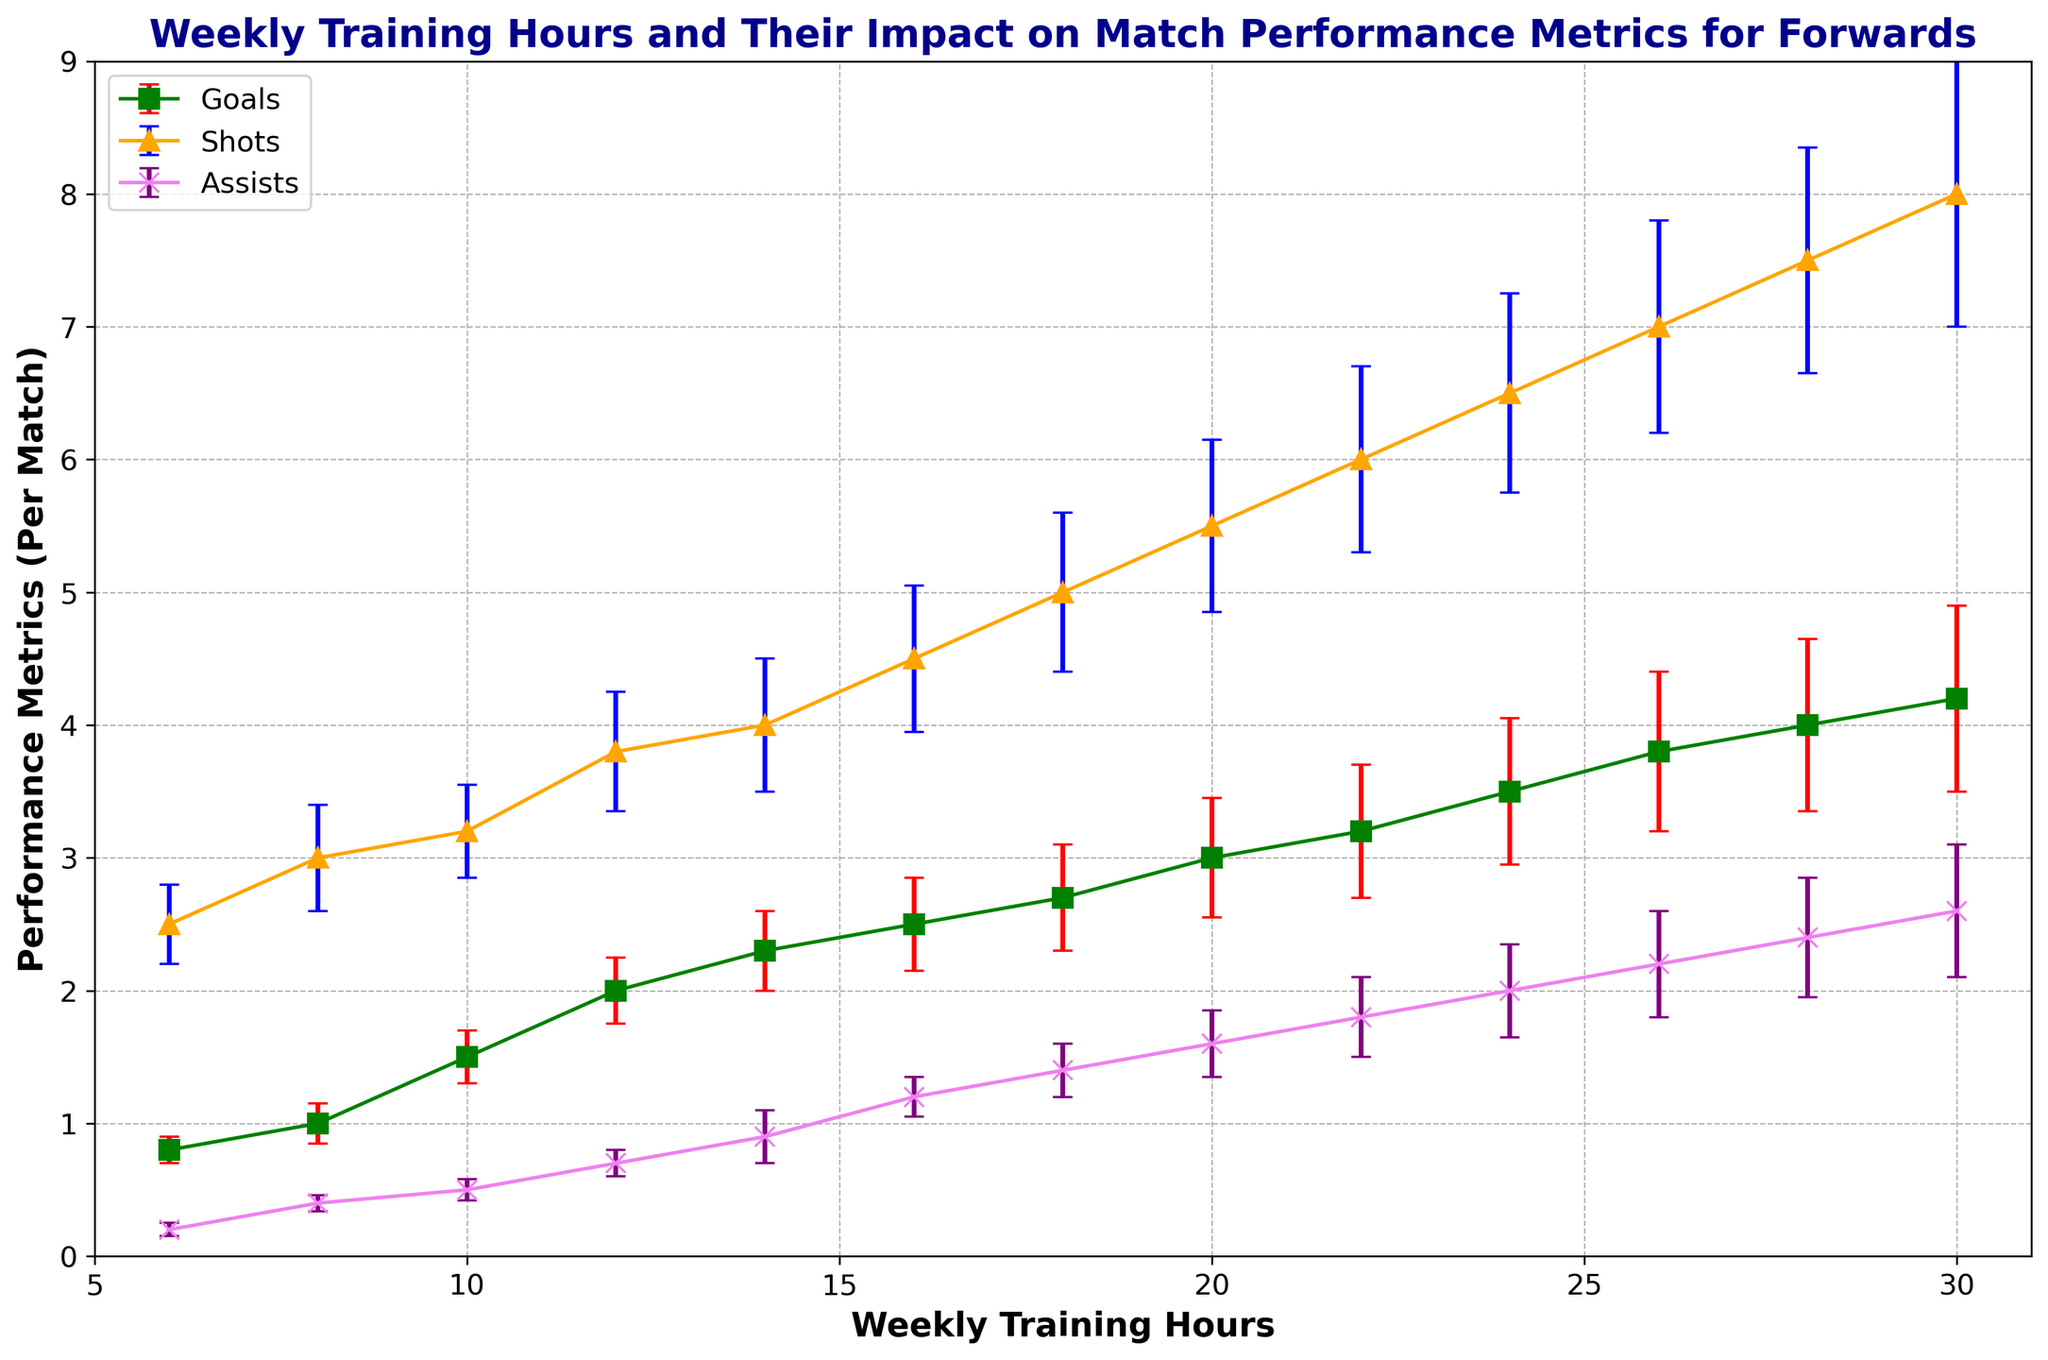What are the error bars representing in this plot? The error bars indicate the variability or uncertainty in the data, specifically highlighting the range within which the true value of the performance metric (Goals, Shots, Assists) is likely to fall.
Answer: Variability/Uncertainty Which metric shows the highest values at 20 weekly training hours? At 20 weekly training hours, the "Shots" metric is the highest compared to Goals and Assists, as its value is marked above both others.
Answer: Shots What is the approximate difference in goals per match between 6 hours and 18 hours of weekly training? At 6 hours, goals per match are approximately 0.8. At 18 hours, goals per match are approximately 2.7. The difference is 2.7 - 0.8 = 1.9.
Answer: 1.9 How does the error bar for goals change as weekly training hours increase from 6 to 30? The error bars for goals increase gradually from 0.1 at 6 hours to 0.7 at 30 hours, indicating higher uncertainty or variability as training hours increase.
Answer: Increase Which performance metric has the smallest error bar consistently? Consistently, the "Assists" metric has the smallest error bars compared to Goals and Shots.
Answer: Assists Is there any metric for which the error bars are always wider than the others? The "Shots" metric generally has wider error bars compared to Goals and Assists throughout the range of weekly training hours.
Answer: Shots At what weekly training hours does the assists metric reach 1 per match, and how does its error bar compare to others at that point? The assists metric reaches 1 per match at approximately 16 weekly training hours. At this point, its error bar is relatively smaller compared to the error bars for Goals and Shots.
Answer: 16 hours, Smaller Which color represents the shots per match in the plot? The color orange is used to represent the shots per match in the plot.
Answer: Orange What can be inferred about the relationship between weekly training hours and goals per match? There is a positive trend: as weekly training hours increase, the number of goals per match also increases. This relationship is visually observable by the upward trajectory of the green line with squares.
Answer: Positive relationship What are the error bar sizes for assists at 26 weekly training hours? The error bar size for assists at 26 weekly training hours is 0.4, as indicated by the height of the error line above and below the data point.
Answer: 0.4 